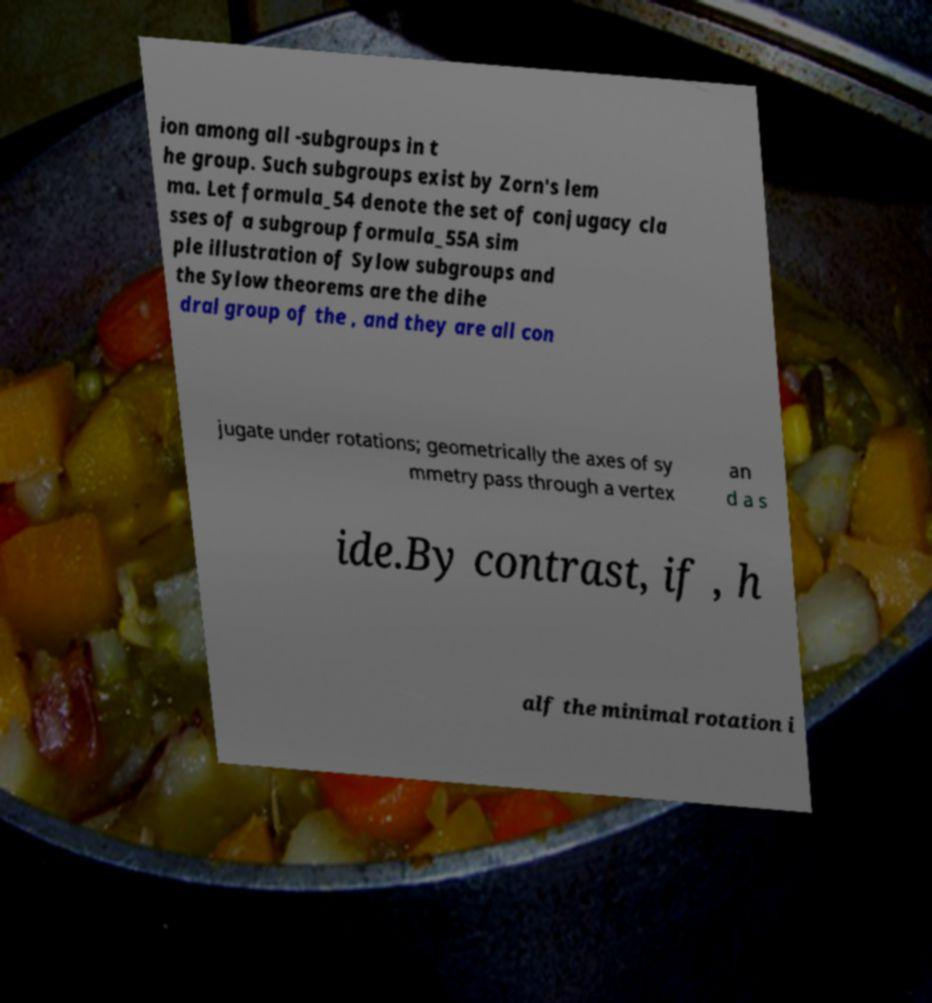For documentation purposes, I need the text within this image transcribed. Could you provide that? ion among all -subgroups in t he group. Such subgroups exist by Zorn's lem ma. Let formula_54 denote the set of conjugacy cla sses of a subgroup formula_55A sim ple illustration of Sylow subgroups and the Sylow theorems are the dihe dral group of the , and they are all con jugate under rotations; geometrically the axes of sy mmetry pass through a vertex an d a s ide.By contrast, if , h alf the minimal rotation i 